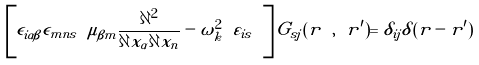<formula> <loc_0><loc_0><loc_500><loc_500>\left [ \epsilon _ { i \alpha \beta } \epsilon _ { m n s } \ \mu _ { \beta m } \frac { \partial ^ { 2 } } { \partial x _ { \alpha } \partial x _ { n } } - \omega _ { k } ^ { 2 } \ \varepsilon _ { i s } \ \right ] \tilde { G } _ { s j } ( { r } \ , \ { r ^ { \prime } } ) = \delta _ { i j } \delta ( { r } - { r ^ { \prime } } )</formula> 